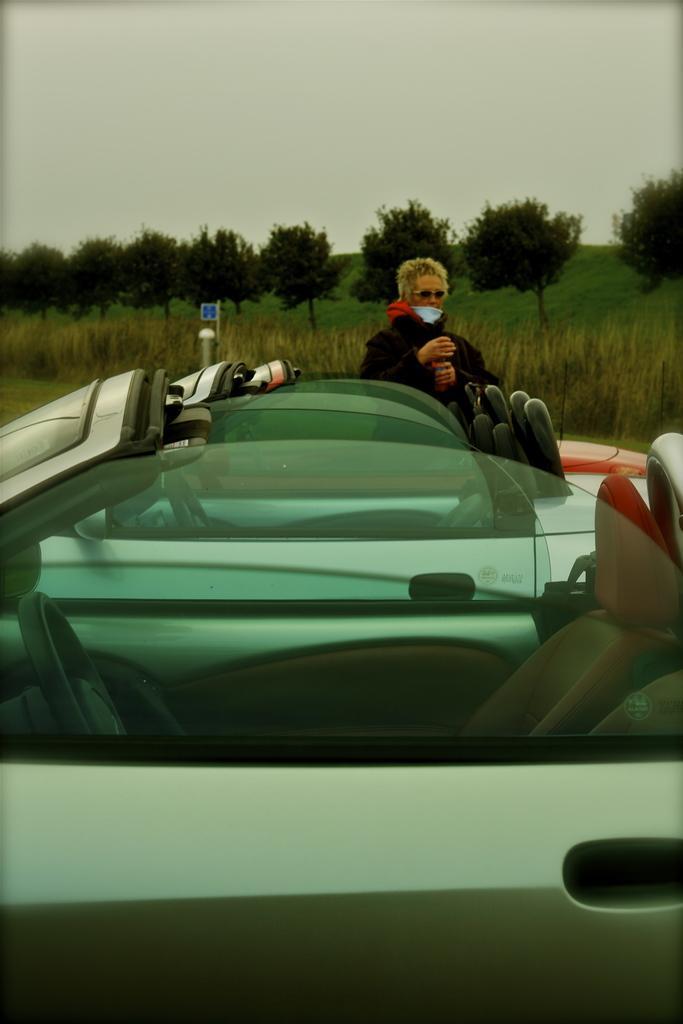In one or two sentences, can you explain what this image depicts? In this image there are three cars one beside the other. In the middle there is a person standing beside the car. In the background there are trees and grass. At the top there is the sky. 